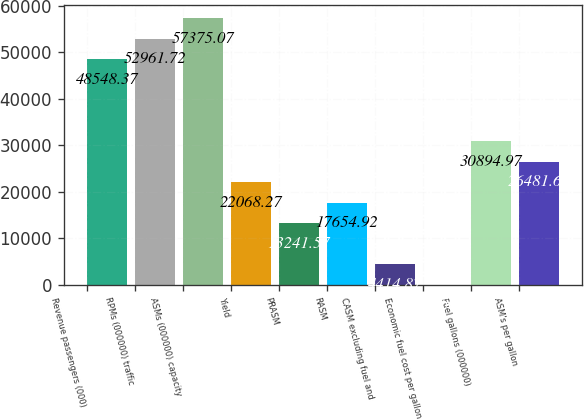<chart> <loc_0><loc_0><loc_500><loc_500><bar_chart><fcel>Revenue passengers (000)<fcel>RPMs (000000) traffic<fcel>ASMs (000000) capacity<fcel>Yield<fcel>PRASM<fcel>RASM<fcel>CASM excluding fuel and<fcel>Economic fuel cost per gallon<fcel>Fuel gallons (000000)<fcel>ASM's per gallon<nl><fcel>48548.4<fcel>52961.7<fcel>57375.1<fcel>22068.3<fcel>13241.6<fcel>17654.9<fcel>4414.87<fcel>1.52<fcel>30895<fcel>26481.6<nl></chart> 